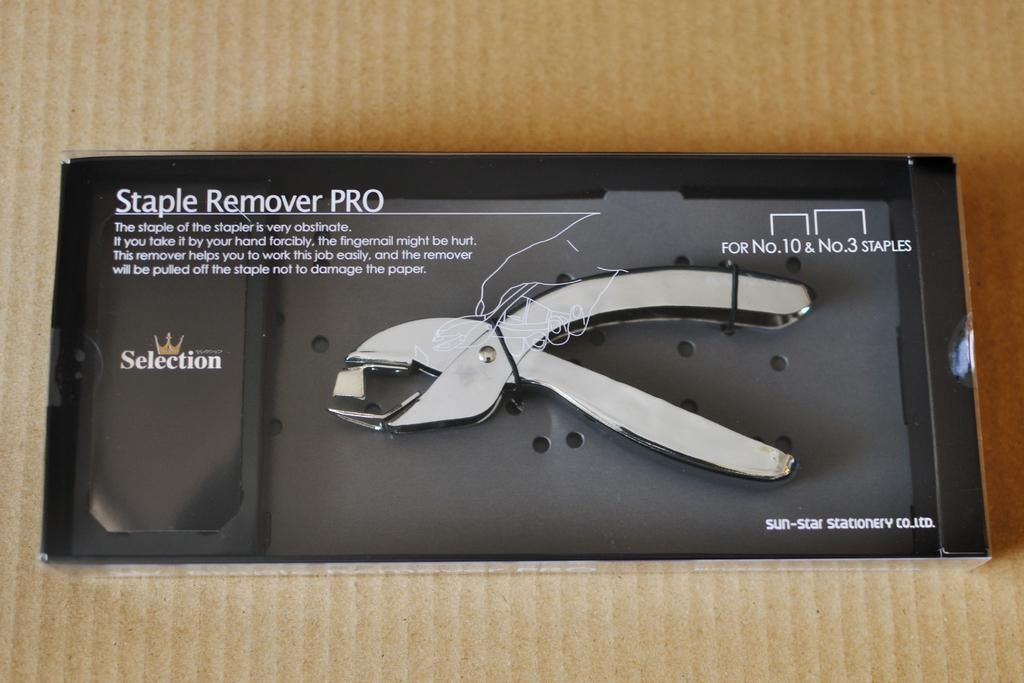What object is the main subject of the image? The main subject of the image is a staple remover. What is the color of the box containing the staple remover? The staple remover is in a black color box. What else can be seen in the image besides the staple remover and the box? There is text visible in the image. What type of gold vase can be seen floating in space in the image? There is no gold vase or space present in the image; it features a staple remover in a black color box with visible text. 